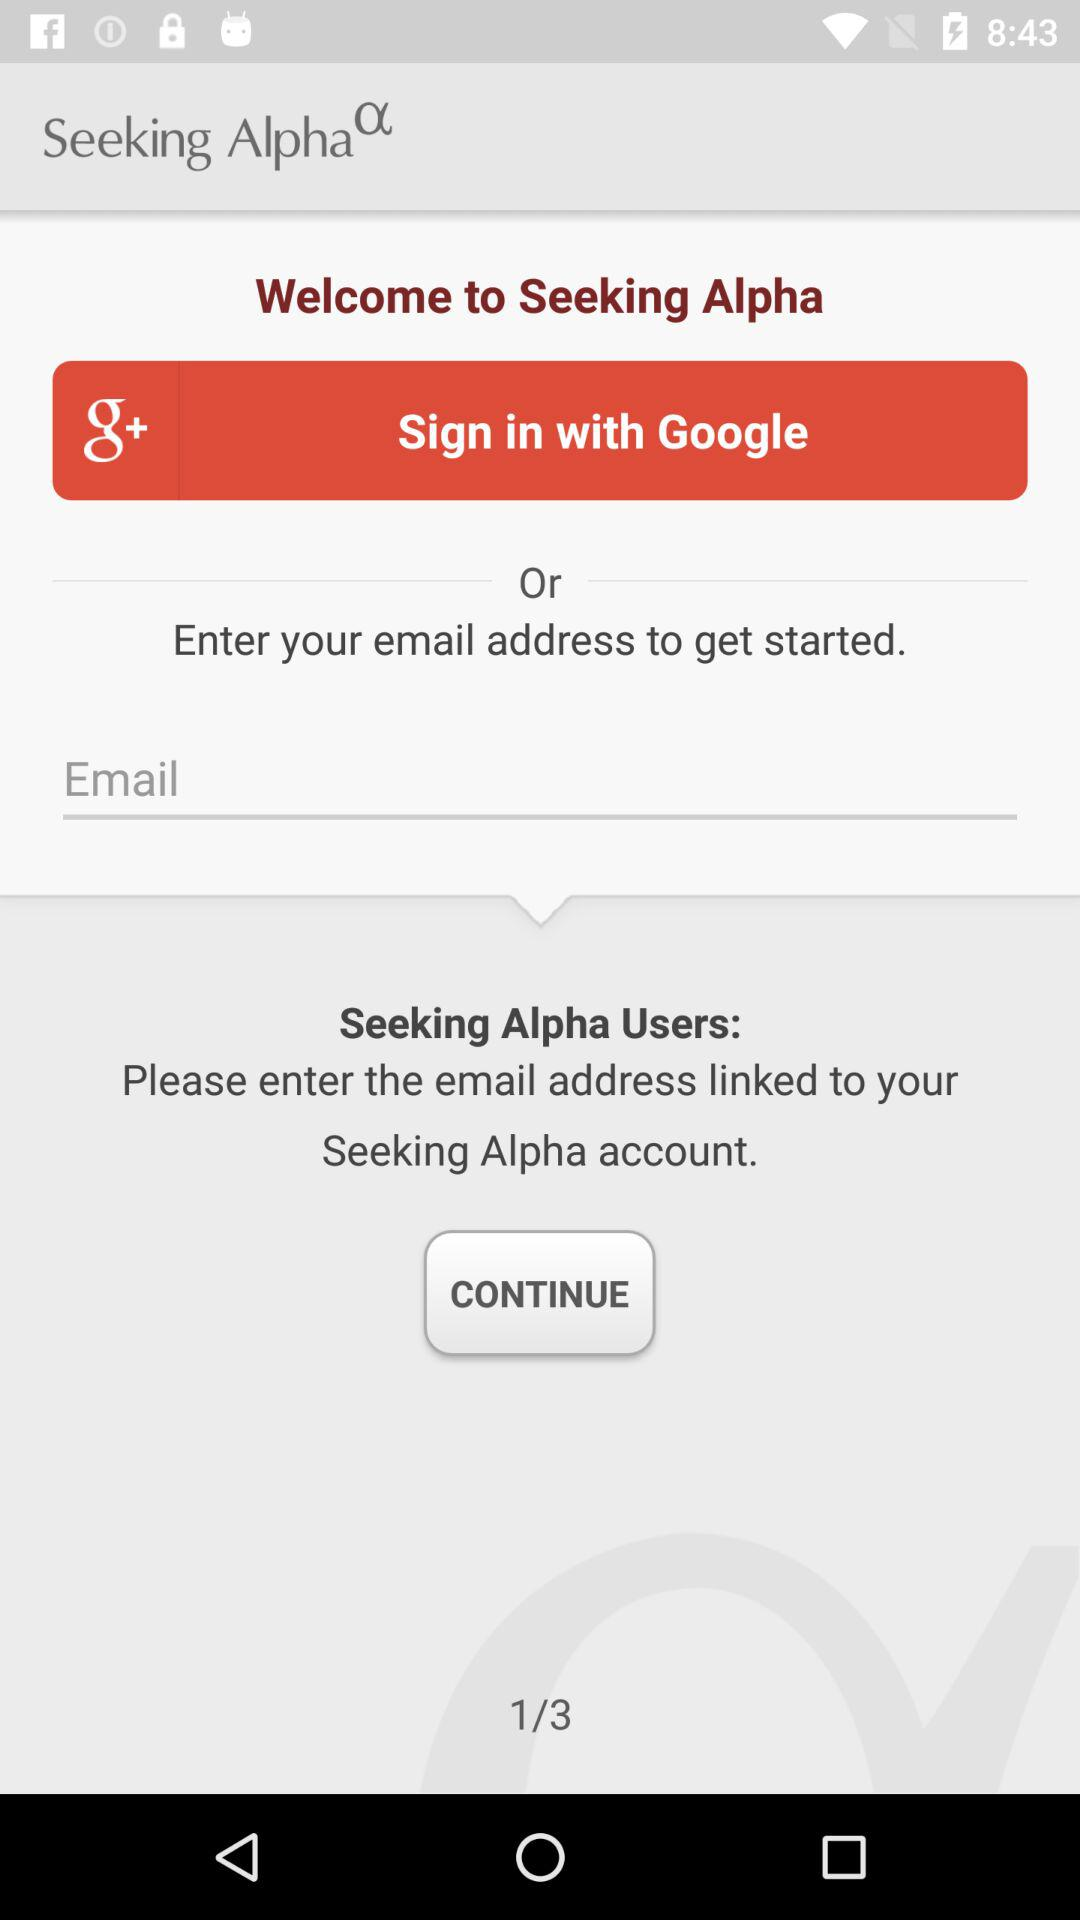How many pages in total are there? There are 3 pages in total. 